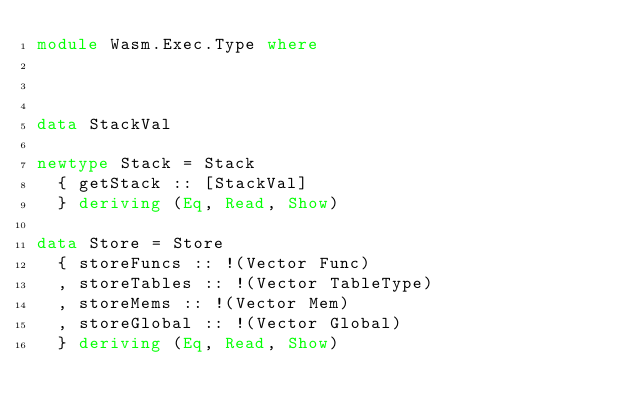Convert code to text. <code><loc_0><loc_0><loc_500><loc_500><_Haskell_>module Wasm.Exec.Type where



data StackVal

newtype Stack = Stack
  { getStack :: [StackVal]
  } deriving (Eq, Read, Show)

data Store = Store
  { storeFuncs :: !(Vector Func)
  , storeTables :: !(Vector TableType)
  , storeMems :: !(Vector Mem)
  , storeGlobal :: !(Vector Global)
  } deriving (Eq, Read, Show)
</code> 